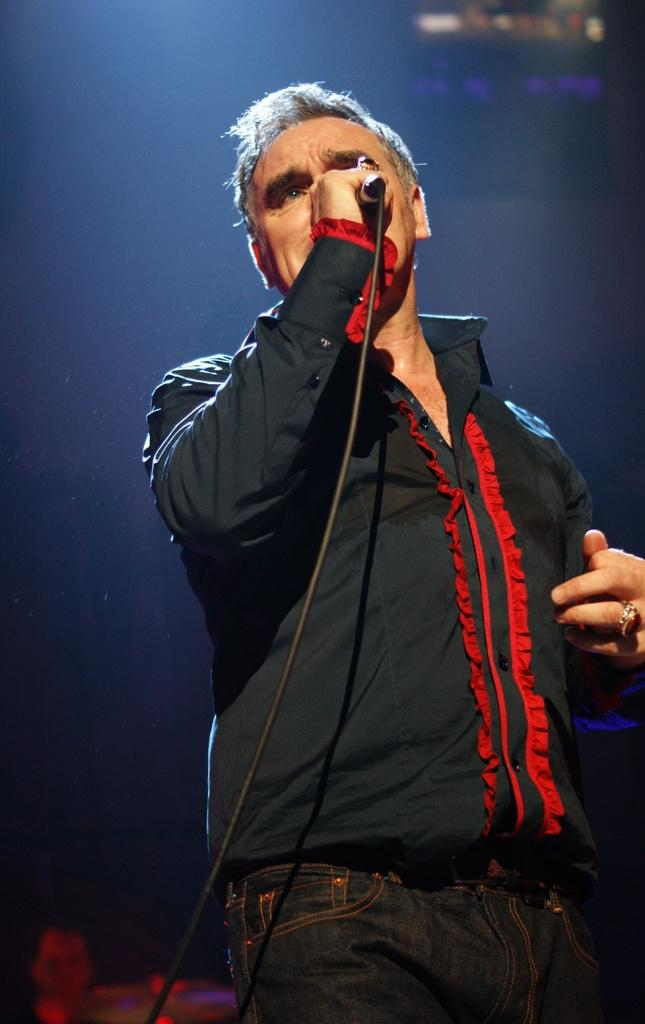Who is the main subject in the image? There is a man in the image. What is the man doing in the image? The man is standing and singing. What tool is the man using while singing? The man is using a microphone. How does the man control the volume of the music while singing? The image does not show any controls for adjusting the volume of the music, so it cannot be determined from the image. 